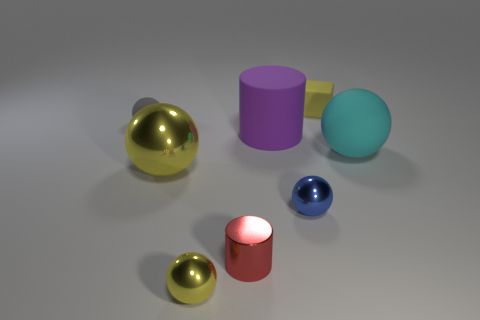What shape is the matte object that is the same color as the big shiny sphere?
Your answer should be compact. Cube. How many rubber things are tiny green cylinders or red cylinders?
Your answer should be very brief. 0. What color is the small sphere behind the large shiny sphere behind the small shiny cylinder that is to the left of the tiny yellow matte thing?
Give a very brief answer. Gray. The other tiny object that is the same shape as the purple rubber thing is what color?
Offer a very short reply. Red. Are there any other things that have the same color as the rubber block?
Provide a succinct answer. Yes. The blue object has what size?
Keep it short and to the point. Small. Are there any large objects that have the same shape as the small gray rubber object?
Your answer should be compact. Yes. What number of objects are either tiny purple balls or tiny yellow things in front of the gray sphere?
Your response must be concise. 1. There is a large ball on the left side of the matte cube; what color is it?
Your response must be concise. Yellow. There is a cylinder that is to the left of the rubber cylinder; is it the same size as the object that is in front of the small metal cylinder?
Your response must be concise. Yes. 